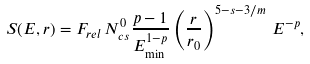Convert formula to latex. <formula><loc_0><loc_0><loc_500><loc_500>S ( E , r ) = F _ { r e l } \, N ^ { 0 } _ { c s } \frac { p - 1 } { E _ { \min } ^ { 1 - p } } \left ( \frac { r } { r _ { 0 } } \right ) ^ { 5 - s - 3 / m } \, E ^ { - p } ,</formula> 